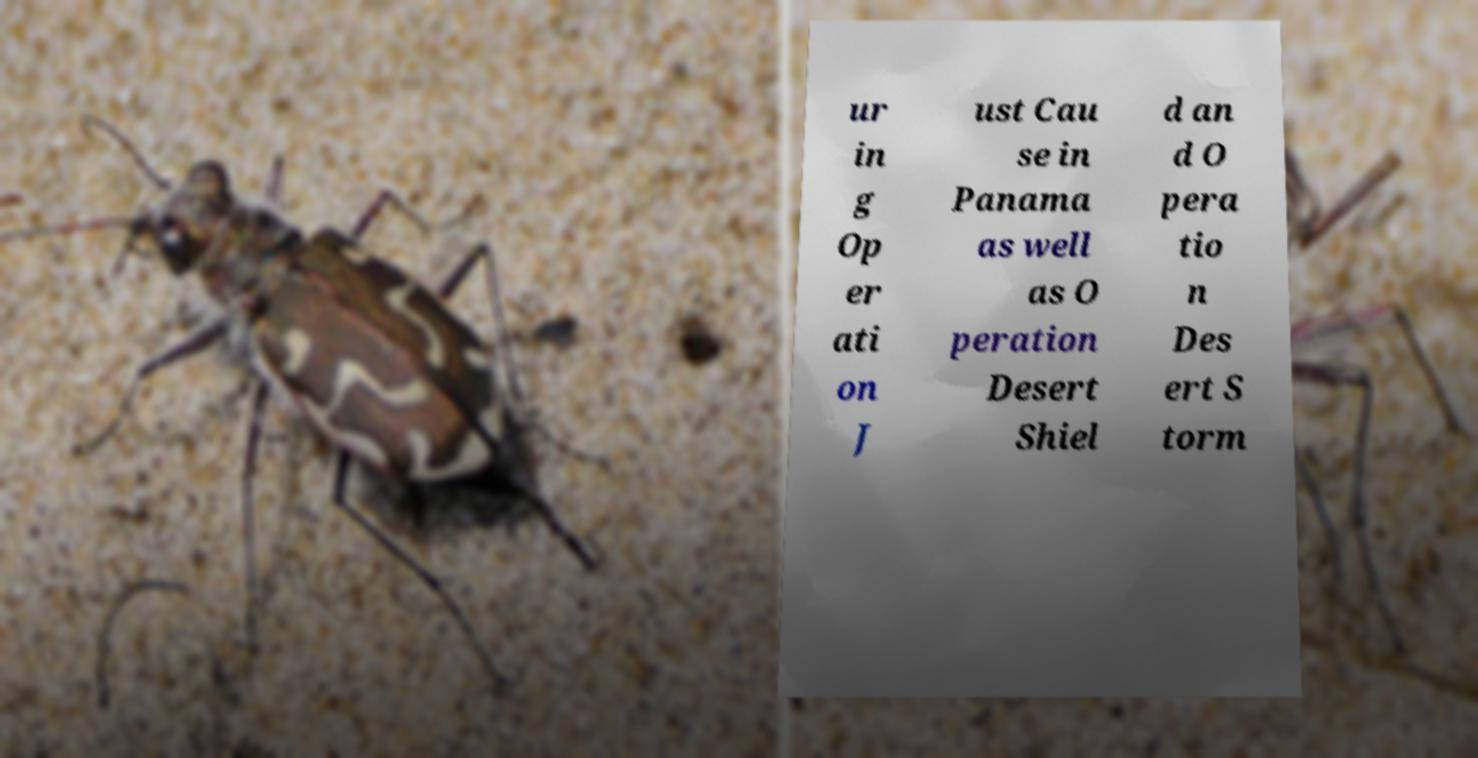Could you assist in decoding the text presented in this image and type it out clearly? ur in g Op er ati on J ust Cau se in Panama as well as O peration Desert Shiel d an d O pera tio n Des ert S torm 